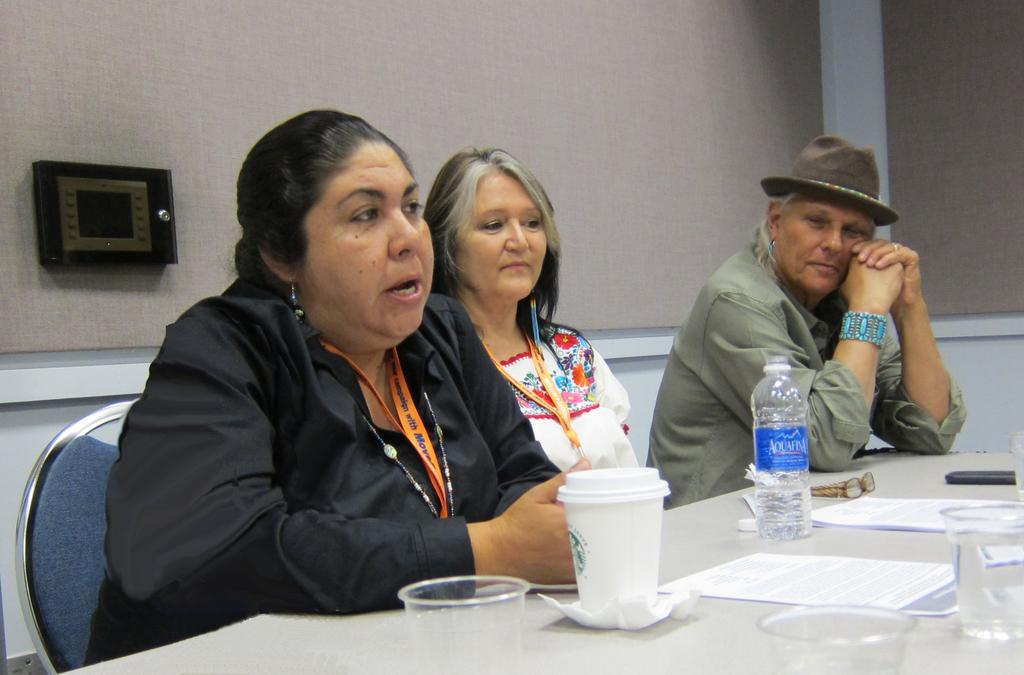How many people are sitting in the image? There are three people sitting in the image. What can be seen on the table in the image? There is a water bottle, glasses, papers, and a spectacle on the table. What is the background of the image? There are walls visible in the background of the image. What type of string is being used to hold up the flowers in the image? There are no flowers or string present in the image. 